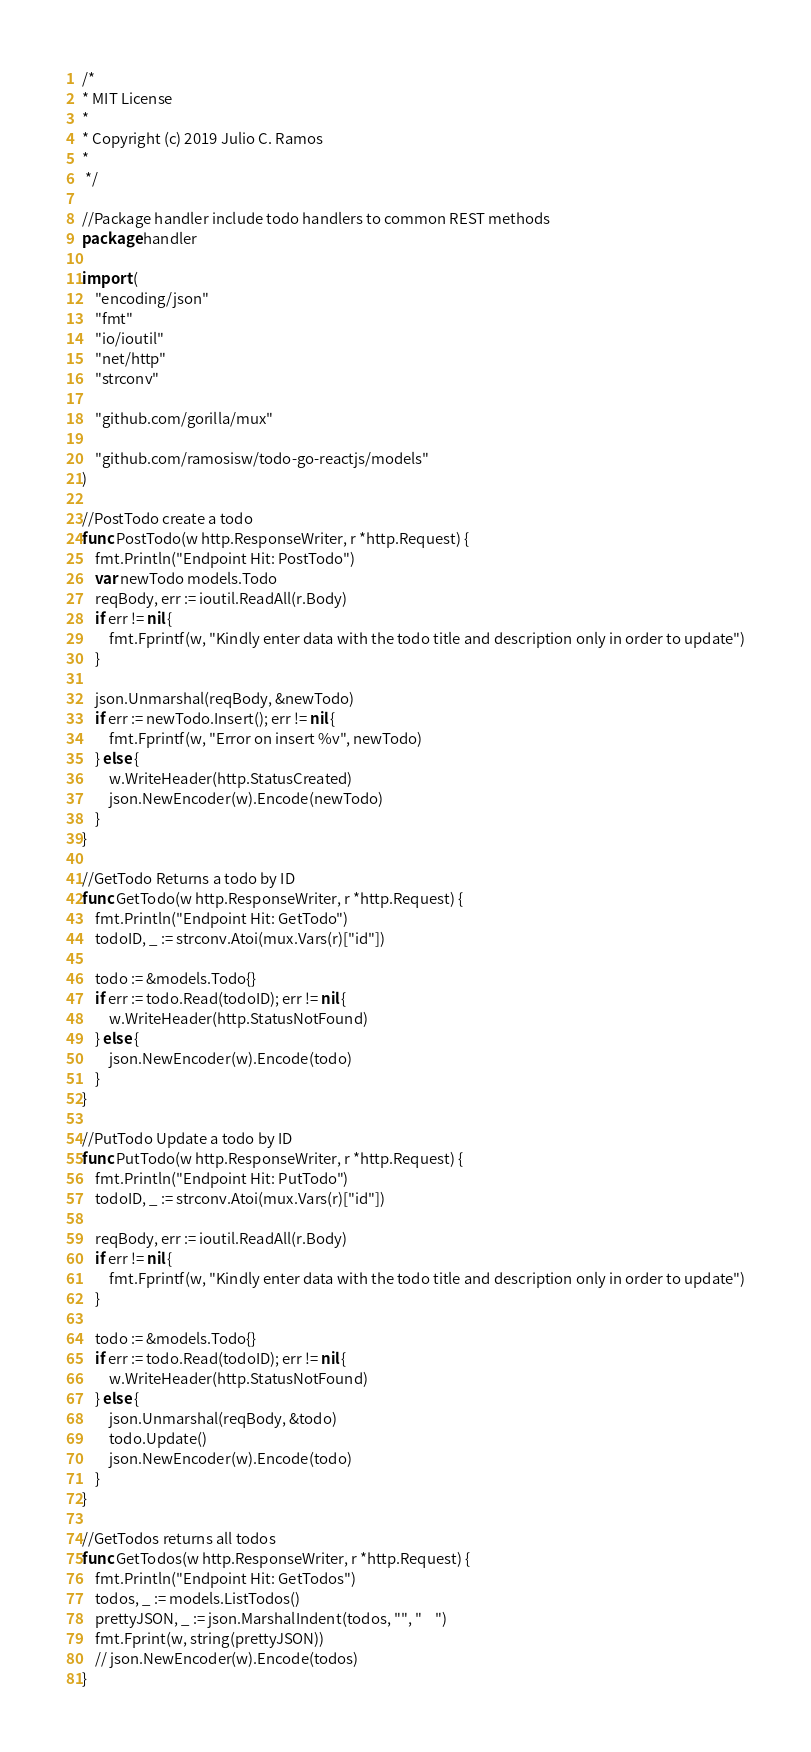<code> <loc_0><loc_0><loc_500><loc_500><_Go_>/*
* MIT License
*
* Copyright (c) 2019 Julio C. Ramos
*
 */

//Package handler include todo handlers to common REST methods
package handler

import (
	"encoding/json"
	"fmt"
	"io/ioutil"
	"net/http"
	"strconv"

	"github.com/gorilla/mux"

	"github.com/ramosisw/todo-go-reactjs/models"
)

//PostTodo create a todo
func PostTodo(w http.ResponseWriter, r *http.Request) {
	fmt.Println("Endpoint Hit: PostTodo")
	var newTodo models.Todo
	reqBody, err := ioutil.ReadAll(r.Body)
	if err != nil {
		fmt.Fprintf(w, "Kindly enter data with the todo title and description only in order to update")
	}

	json.Unmarshal(reqBody, &newTodo)
	if err := newTodo.Insert(); err != nil {
		fmt.Fprintf(w, "Error on insert %v", newTodo)
	} else {
		w.WriteHeader(http.StatusCreated)
		json.NewEncoder(w).Encode(newTodo)
	}
}

//GetTodo Returns a todo by ID
func GetTodo(w http.ResponseWriter, r *http.Request) {
	fmt.Println("Endpoint Hit: GetTodo")
	todoID, _ := strconv.Atoi(mux.Vars(r)["id"])

	todo := &models.Todo{}
	if err := todo.Read(todoID); err != nil {
		w.WriteHeader(http.StatusNotFound)
	} else {
		json.NewEncoder(w).Encode(todo)
	}
}

//PutTodo Update a todo by ID
func PutTodo(w http.ResponseWriter, r *http.Request) {
	fmt.Println("Endpoint Hit: PutTodo")
	todoID, _ := strconv.Atoi(mux.Vars(r)["id"])

	reqBody, err := ioutil.ReadAll(r.Body)
	if err != nil {
		fmt.Fprintf(w, "Kindly enter data with the todo title and description only in order to update")
	}

	todo := &models.Todo{}
	if err := todo.Read(todoID); err != nil {
		w.WriteHeader(http.StatusNotFound)
	} else {
		json.Unmarshal(reqBody, &todo)
		todo.Update()
		json.NewEncoder(w).Encode(todo)
	}
}

//GetTodos returns all todos
func GetTodos(w http.ResponseWriter, r *http.Request) {
	fmt.Println("Endpoint Hit: GetTodos")
	todos, _ := models.ListTodos()
	prettyJSON, _ := json.MarshalIndent(todos, "", "    ")
	fmt.Fprint(w, string(prettyJSON))
	// json.NewEncoder(w).Encode(todos)
}
</code> 